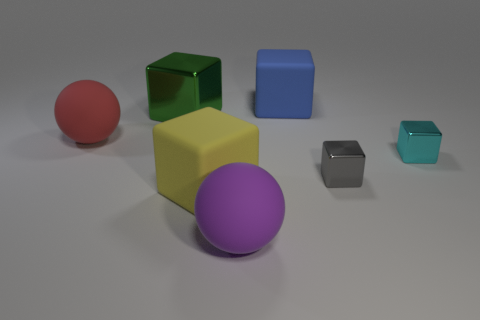Subtract all big blue matte cubes. How many cubes are left? 4 Subtract all blue cubes. How many cubes are left? 4 Subtract 2 cubes. How many cubes are left? 3 Subtract all brown blocks. Subtract all cyan cylinders. How many blocks are left? 5 Add 2 small blue cylinders. How many objects exist? 9 Subtract all cubes. How many objects are left? 2 Add 5 big blue things. How many big blue things are left? 6 Add 2 blue blocks. How many blue blocks exist? 3 Subtract 0 cyan spheres. How many objects are left? 7 Subtract all small metallic objects. Subtract all large metallic cylinders. How many objects are left? 5 